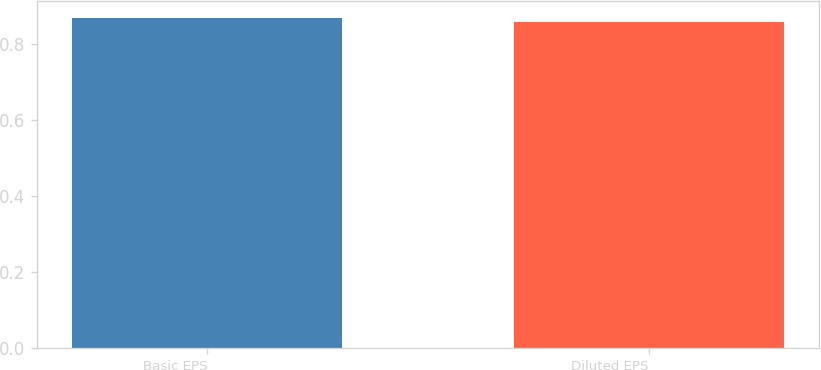<chart> <loc_0><loc_0><loc_500><loc_500><bar_chart><fcel>Basic EPS<fcel>Diluted EPS<nl><fcel>0.87<fcel>0.86<nl></chart> 